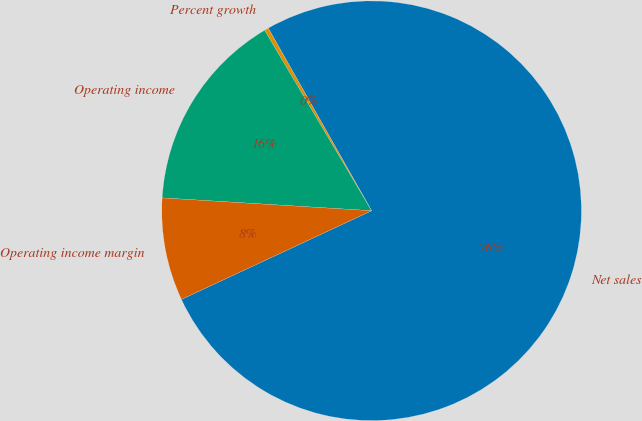<chart> <loc_0><loc_0><loc_500><loc_500><pie_chart><fcel>Net sales<fcel>Percent growth<fcel>Operating income<fcel>Operating income margin<nl><fcel>76.25%<fcel>0.32%<fcel>15.51%<fcel>7.92%<nl></chart> 